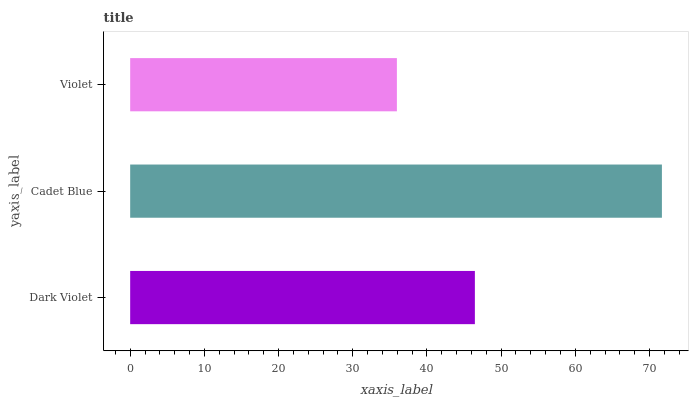Is Violet the minimum?
Answer yes or no. Yes. Is Cadet Blue the maximum?
Answer yes or no. Yes. Is Cadet Blue the minimum?
Answer yes or no. No. Is Violet the maximum?
Answer yes or no. No. Is Cadet Blue greater than Violet?
Answer yes or no. Yes. Is Violet less than Cadet Blue?
Answer yes or no. Yes. Is Violet greater than Cadet Blue?
Answer yes or no. No. Is Cadet Blue less than Violet?
Answer yes or no. No. Is Dark Violet the high median?
Answer yes or no. Yes. Is Dark Violet the low median?
Answer yes or no. Yes. Is Violet the high median?
Answer yes or no. No. Is Violet the low median?
Answer yes or no. No. 